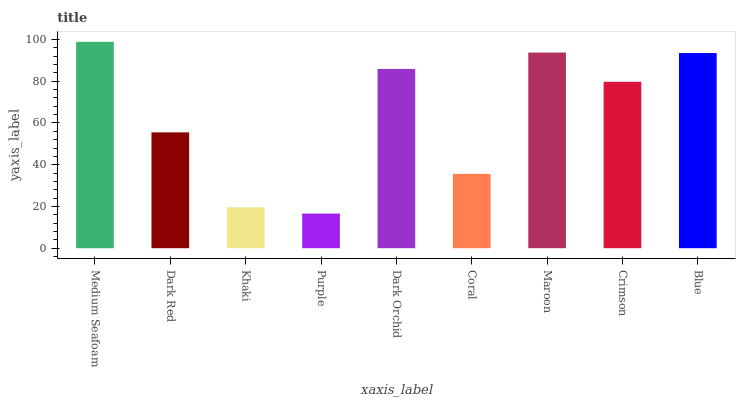Is Dark Red the minimum?
Answer yes or no. No. Is Dark Red the maximum?
Answer yes or no. No. Is Medium Seafoam greater than Dark Red?
Answer yes or no. Yes. Is Dark Red less than Medium Seafoam?
Answer yes or no. Yes. Is Dark Red greater than Medium Seafoam?
Answer yes or no. No. Is Medium Seafoam less than Dark Red?
Answer yes or no. No. Is Crimson the high median?
Answer yes or no. Yes. Is Crimson the low median?
Answer yes or no. Yes. Is Khaki the high median?
Answer yes or no. No. Is Khaki the low median?
Answer yes or no. No. 